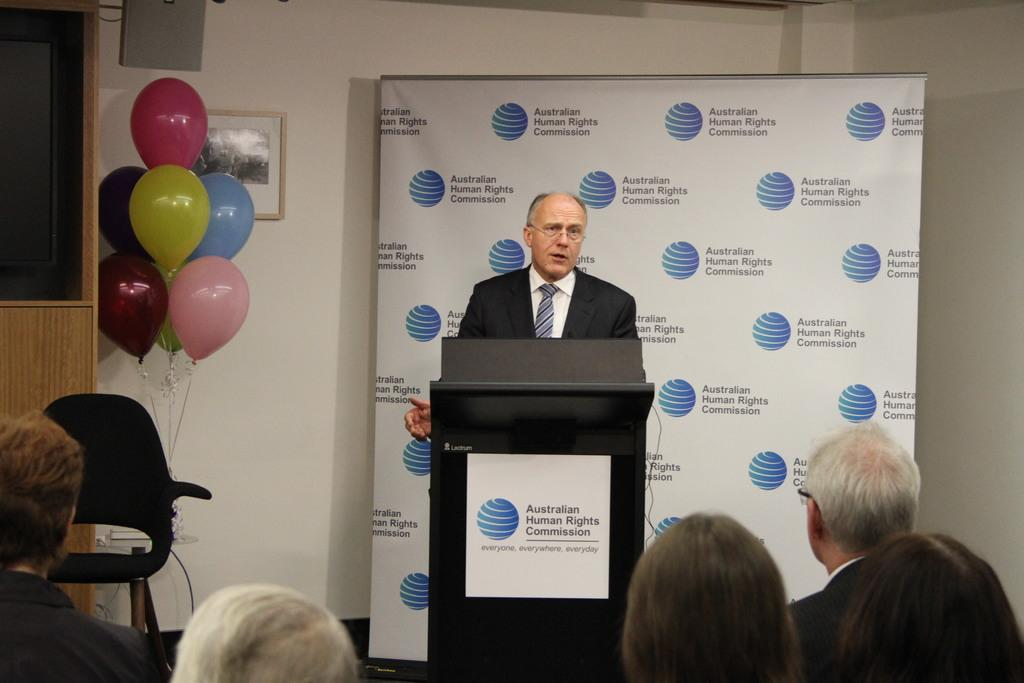<image>
Create a compact narrative representing the image presented. A man standing behind the Australian human rights commission podium 